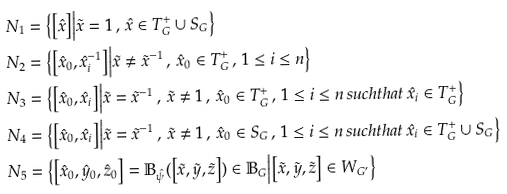<formula> <loc_0><loc_0><loc_500><loc_500>N _ { 1 } & = \Big \{ \Big [ \hat { x } \Big ] \Big | \tilde { x } = 1 \, , \, \hat { x } \in T _ { G } ^ { + } \cup S _ { G } \Big \} \\ N _ { 2 } & = \Big \{ \Big [ \hat { x } _ { 0 } , \hat { x } _ { i } ^ { - 1 } \Big ] \Big | \tilde { x } \neq \tilde { x } ^ { - 1 } \, , \, \hat { x } _ { 0 } \in T _ { G } ^ { + } \, , \, 1 \leq i \leq n \Big \} \\ N _ { 3 } & = \Big \{ \Big [ \hat { x } _ { 0 } , \hat { x } _ { i } \Big ] \Big | \tilde { x } = \tilde { x } ^ { - 1 } \, , \, \tilde { x } \neq 1 \, , \, \hat { x } _ { 0 } \in T _ { G } ^ { + } \, , \, 1 \leq i \leq n \, s u c h t h a t \, \hat { x } _ { i } \in T _ { G } ^ { + } \Big \} \\ N _ { 4 } & = \Big \{ \Big [ \hat { x } _ { 0 } , \hat { x } _ { i } \Big ] \Big | \tilde { x } = \tilde { x } ^ { - 1 } \, , \, \tilde { x } \neq 1 \, , \, \hat { x } _ { 0 } \in S _ { G } \, , \, 1 \leq i \leq n \, s u c h t h a t \, \hat { x } _ { i } \in T _ { G } ^ { + } \cup S _ { G } \Big \} \\ N _ { 5 } & = \Big \{ \Big [ \hat { x } _ { 0 } , \hat { y } _ { 0 } , \hat { z } _ { 0 } \Big ] = \mathbb { B } _ { \hat { \psi } } ( \Big [ \tilde { x } , \tilde { y } , \tilde { z } \Big ] ) \in \mathbb { B } _ { G } \Big | \Big [ \tilde { x } , \tilde { y } , \tilde { z } \Big ] \in W _ { G ^ { \prime } } \Big \}</formula> 